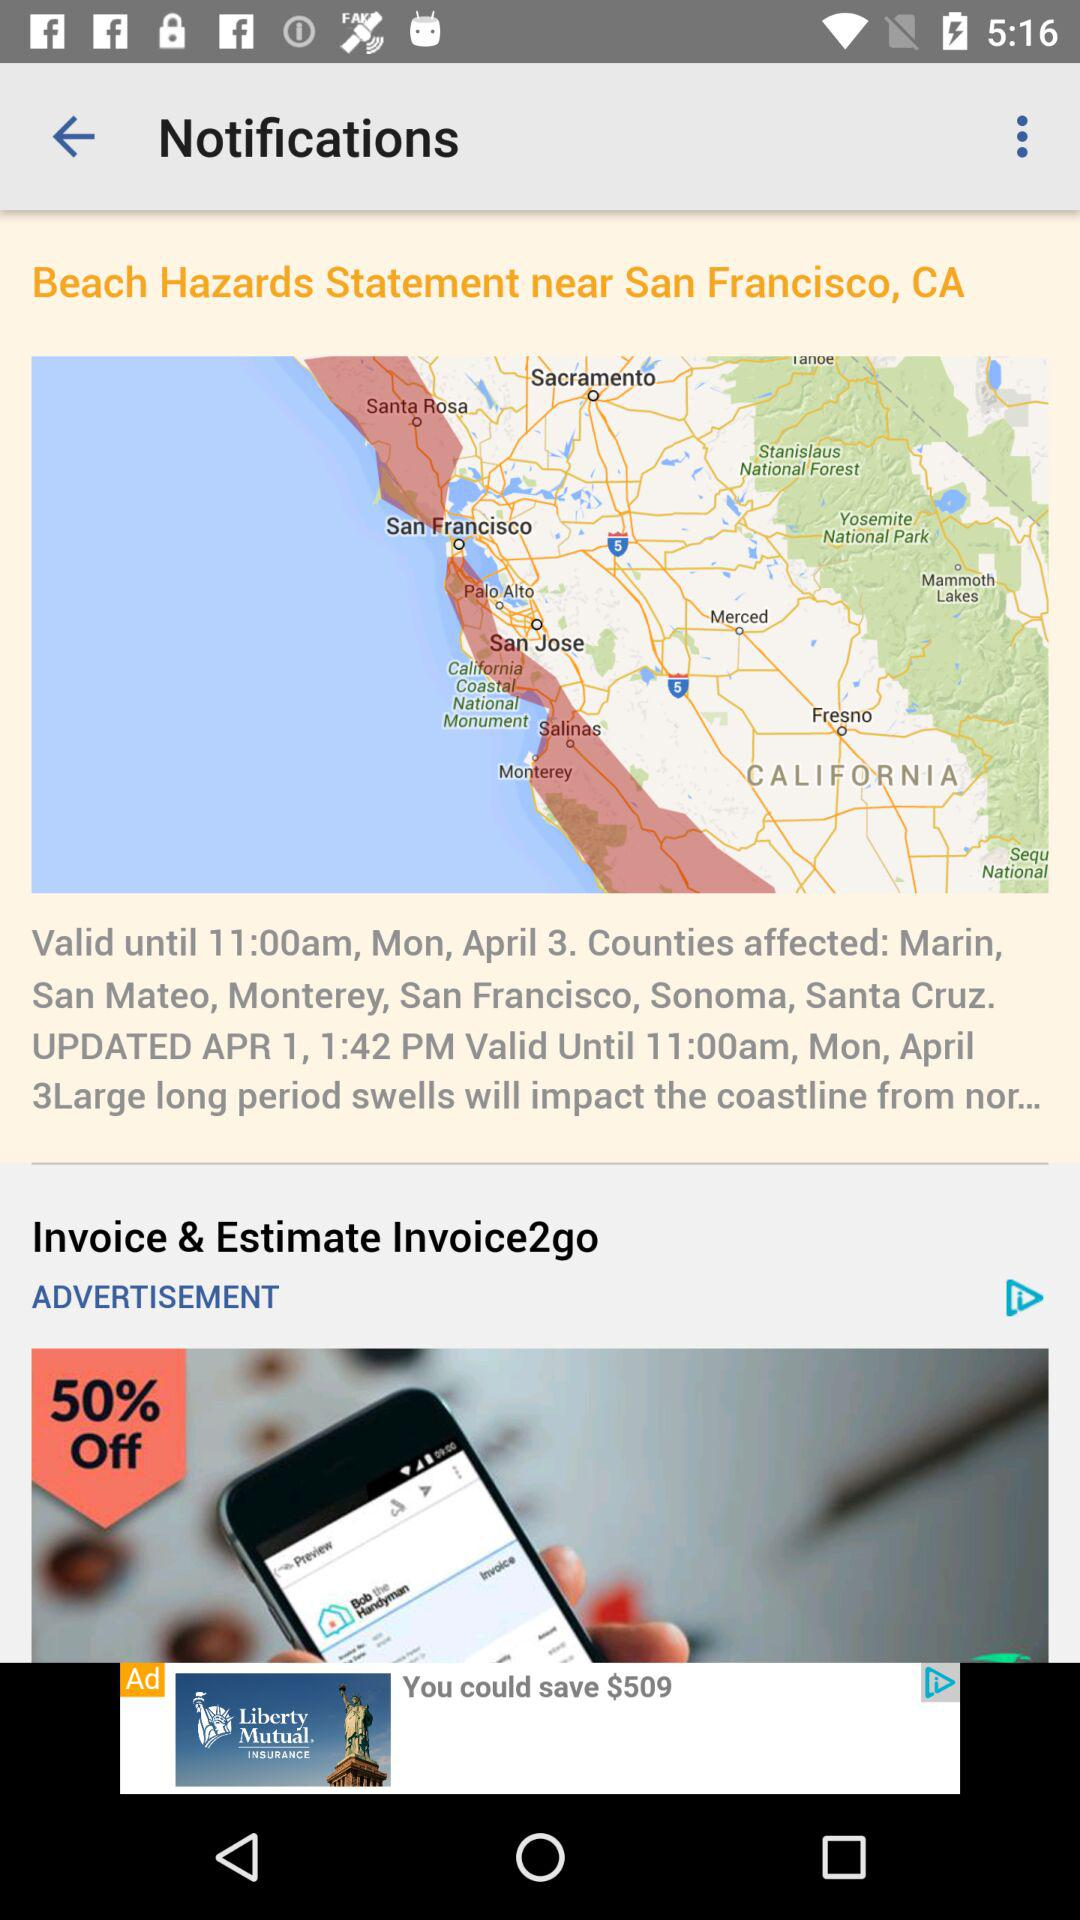How many counties are affected by the beach hazard statement?
Answer the question using a single word or phrase. 6 